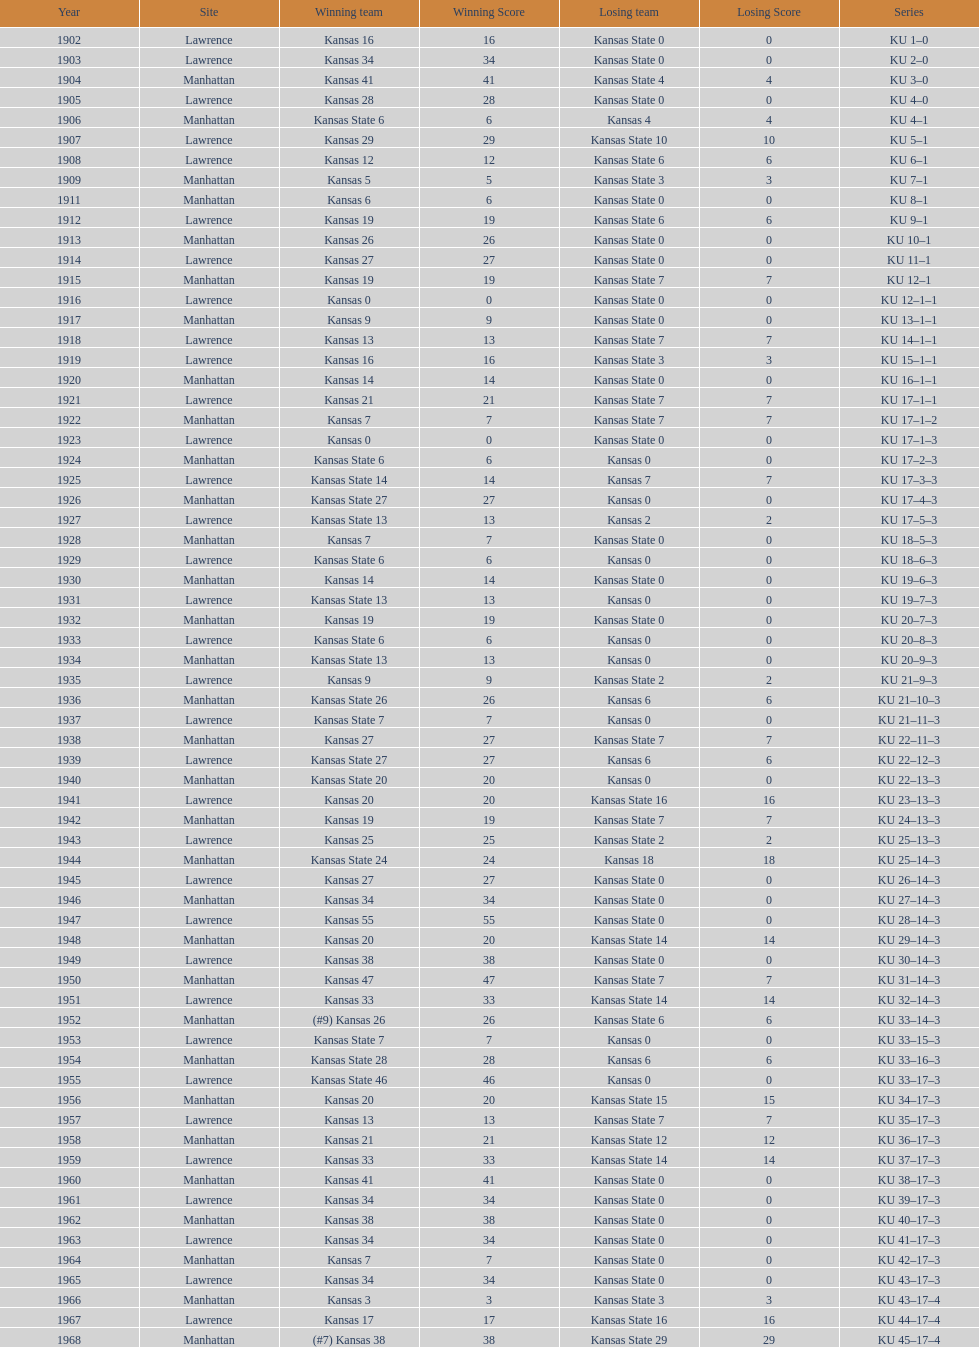Who had the most wins in the 1950's: kansas or kansas state? Kansas. 